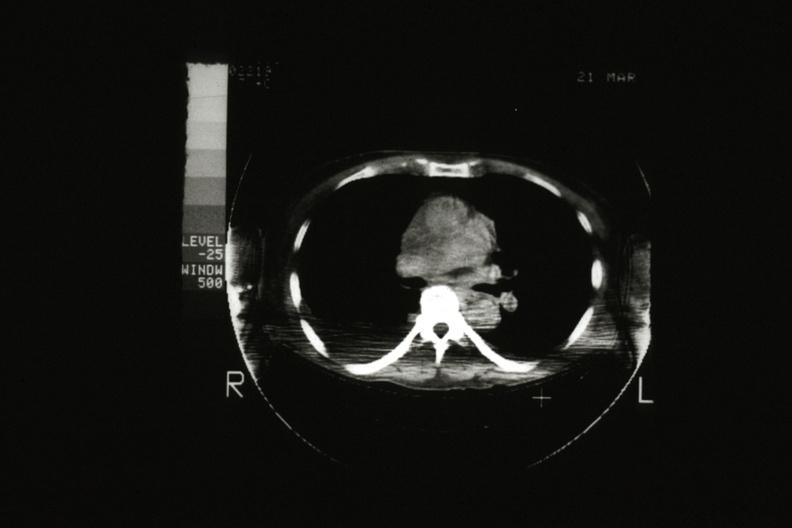s hematologic present?
Answer the question using a single word or phrase. Yes 